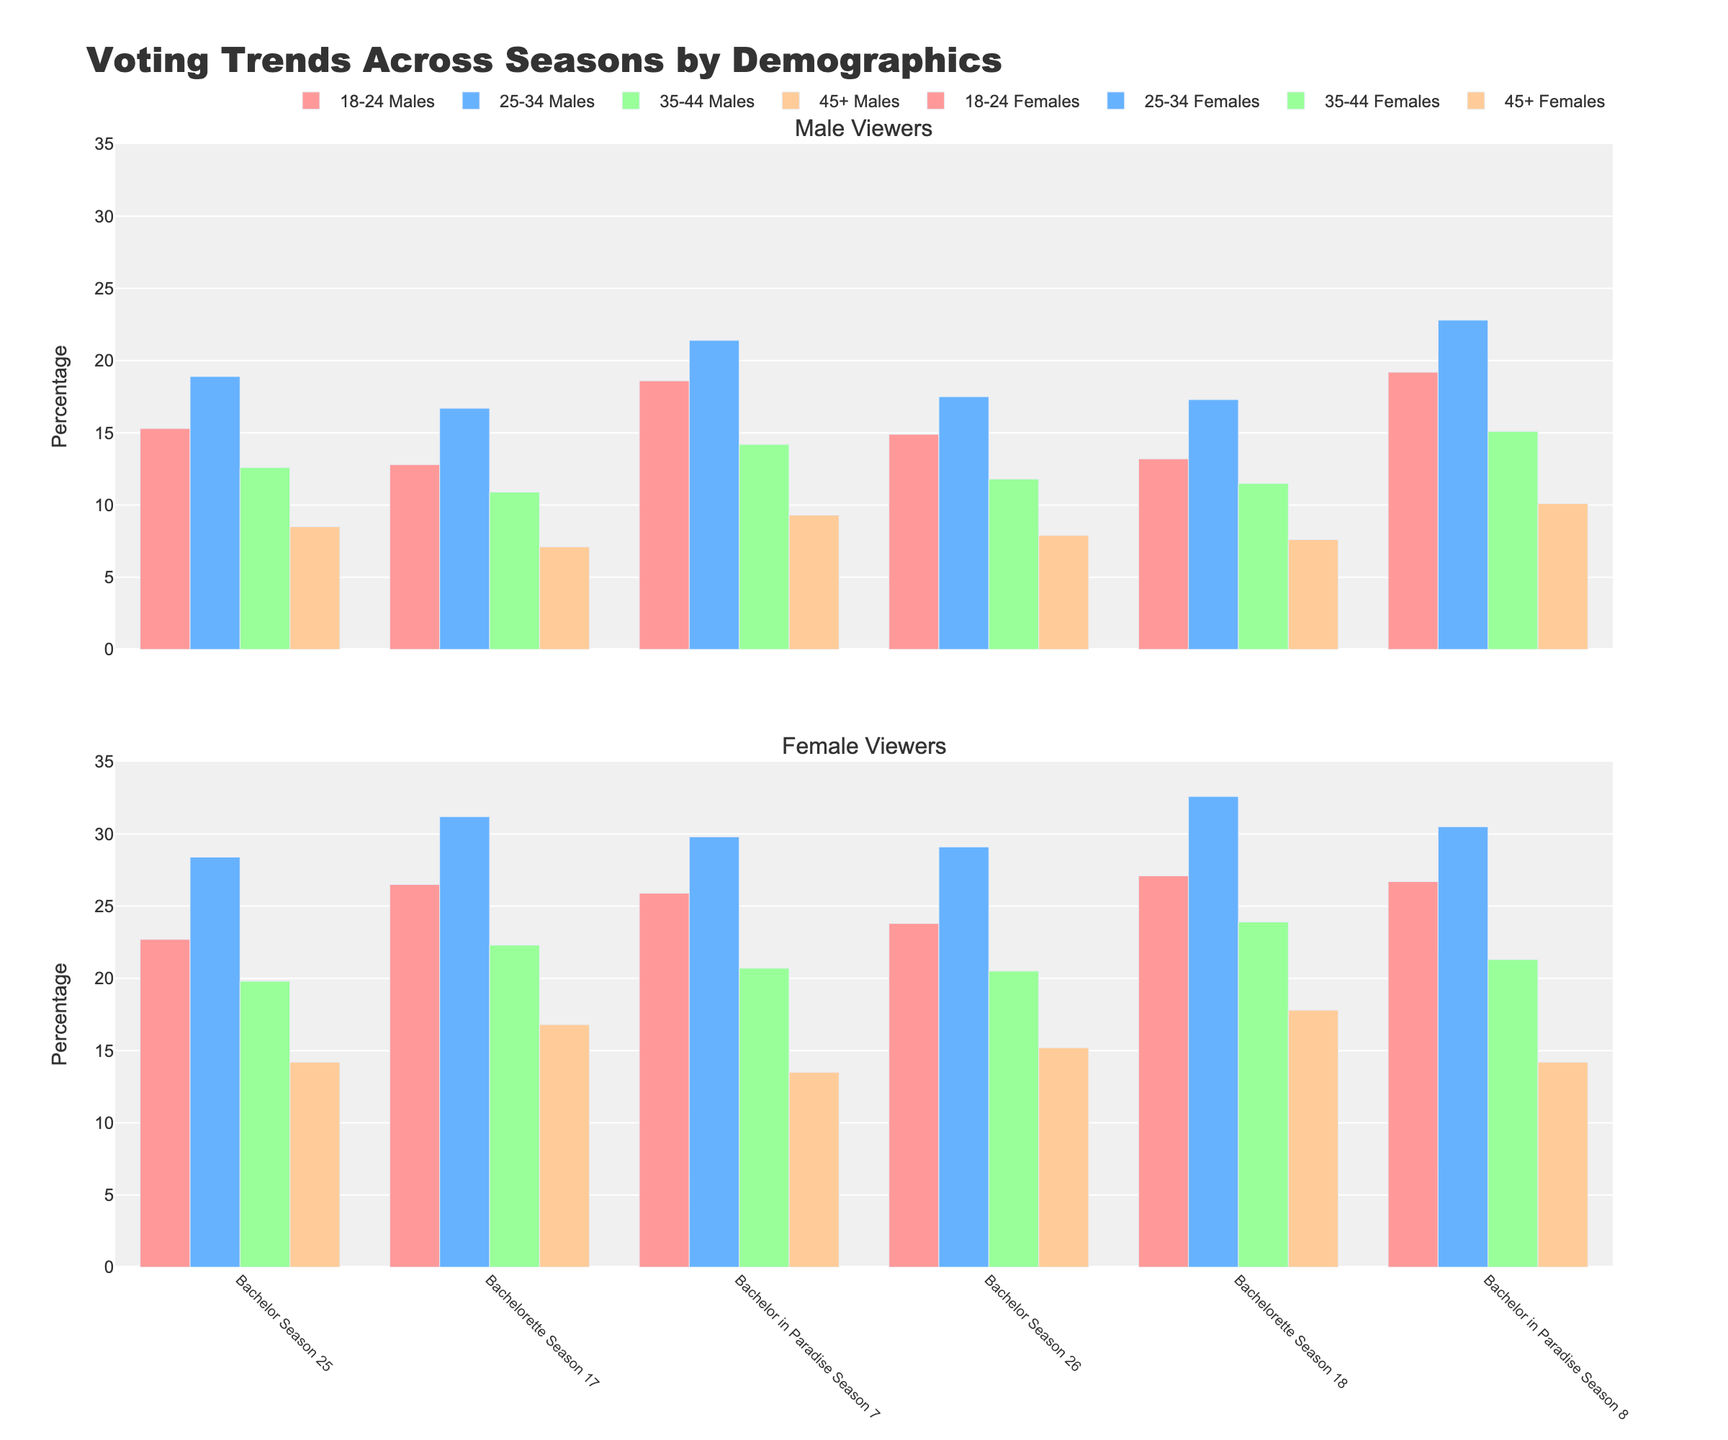What is the difference in voting percentage for 18-24 Females between 'Bachelor Season 25' and 'Bachelorette Season 17'? The voting percentage for 18-24 Females in 'Bachelor Season 25' is 22.7%. In 'Bachelorette Season 17', it is 26.5%. The difference is calculated by subtracting 22.7 from 26.5 which equals 3.8%.
Answer: 3.8% Which season had the highest voting percentage from 25-34 Females? Looking at the bars for 25-34 Females across all seasons, 'Bachelorette Season 18' has the tallest bar, indicating the highest voting percentage at 32.6%.
Answer: Bachelorette Season 18 What is the total voting percentage of 35-44 Males in all seasons combined? The voting percentages for 35-44 Males across the seasons are 12.6, 10.9, 14.2, 11.8, 11.5, and 15.1. Summing these gives: 12.6 + 10.9 + 14.2 + 11.8 + 11.5 + 15.1 = 76.1%.
Answer: 76.1% What is the average voting percentage for 45+ Females across all seasons? The voting percentages for 45+ Females across all seasons are 14.2%, 16.8%, 13.5%, 15.2%, 17.8%, and 14.2%. Adding these gives 91.7%, and dividing by 6 (number of seasons) gives an average of 15.28%.
Answer: 15.28% Which season had a higher voting percentage for 18-24 Males: 'Bachelor Season 26' or 'Bachelorette Season 18'? The voting percentage for 18-24 Males in 'Bachelor Season 26' is 14.9%, and in 'Bachelorette Season 18' it is 13.2%. 14.9% is greater than 13.2%, so 'Bachelor Season 26' had a higher voting percentage.
Answer: Bachelor Season 26 Compare the voting percentages for 25-34 Males and 35-44 Females in 'Bachelor in Paradise Season 8'. Which demographic had a higher percentage? The voting percentage for 25-34 Males in 'Bachelor in Paradise Season 8' is 22.8%, while for 35-44 Females it is 21.3%. 22.8% is greater than 21.3%, so 25-34 Males had a higher percentage.
Answer: 25-34 Males What is the visual difference in bar height between 18-24 Females and 18-24 Males in 'Bachelor in Paradise Season 8'? In 'Bachelor in Paradise Season 8', the bar representing 18-24 Females is taller than that of 18-24 Males, indicating a higher voting percentage. The specific values are 26.7% for 18-24 Females and 19.2% for 18-24 Males, showing a difference of 7.5 percentage points.
Answer: 7.5 percentage points By how much did the voting percentage for 45+ Males change from 'Bachelor Season 25' to 'Bachelor in Paradise Season 7'? The voting percentage for 45+ Males in 'Bachelor Season 25' is 8.5%, and in 'Bachelor in Paradise Season 7' it is 9.3%. The change is calculated by subtracting 8.5 from 9.3, which gives a change of 0.8 percentage points.
Answer: 0.8 percentage points 